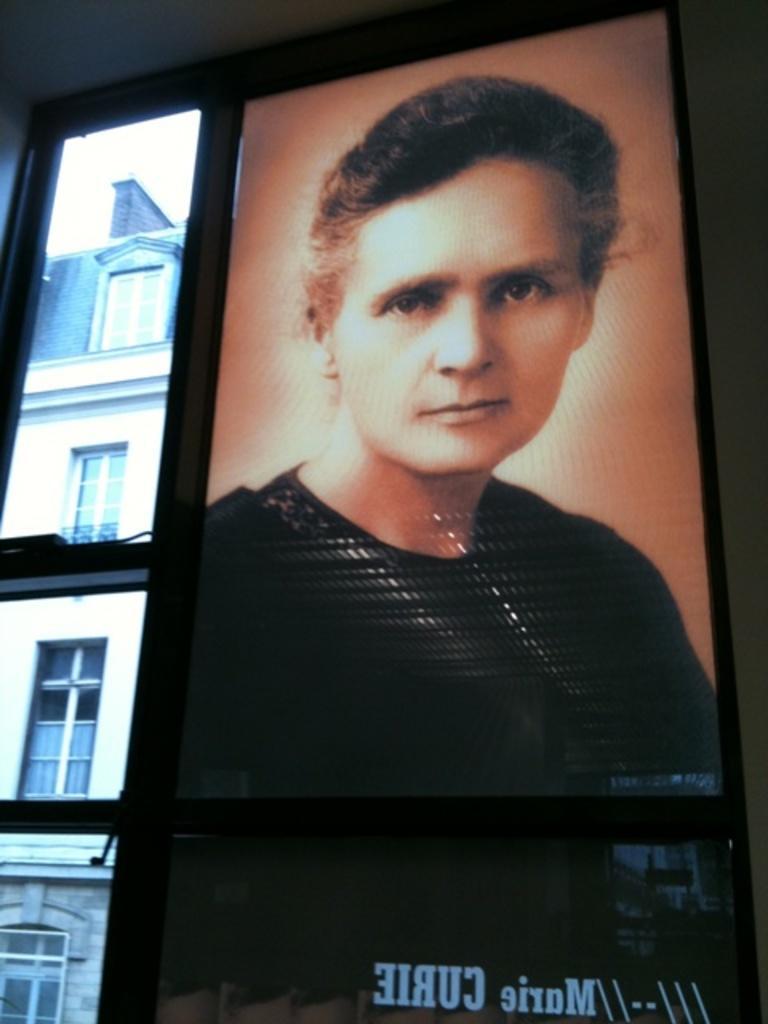Describe this image in one or two sentences. In this picture we can see a poster on the window, in the background we can see a building. 